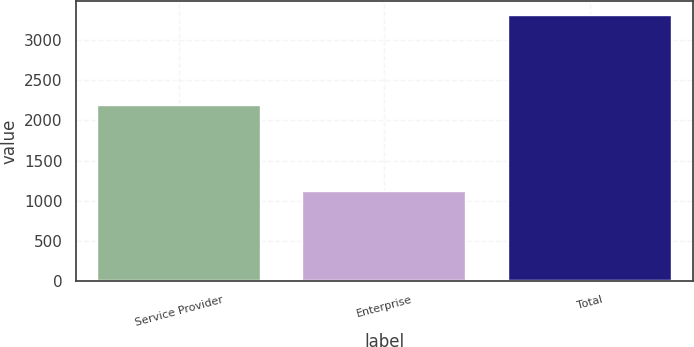<chart> <loc_0><loc_0><loc_500><loc_500><bar_chart><fcel>Service Provider<fcel>Enterprise<fcel>Total<nl><fcel>2197.1<fcel>1118.8<fcel>3315.9<nl></chart> 